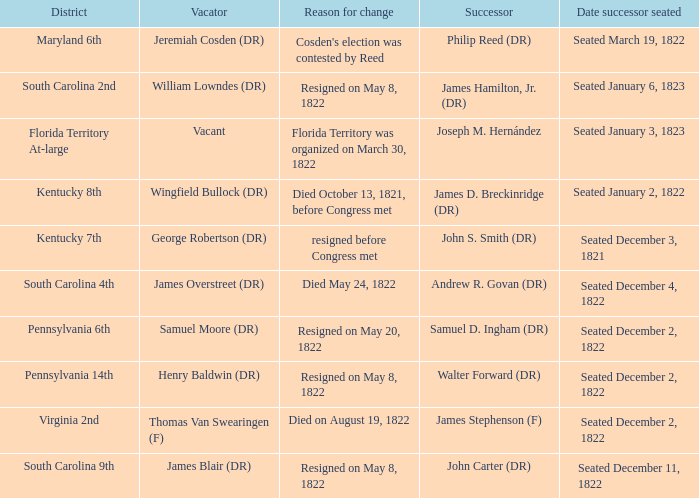Who is the vacator when south carolina 4th is the district? James Overstreet (DR). 